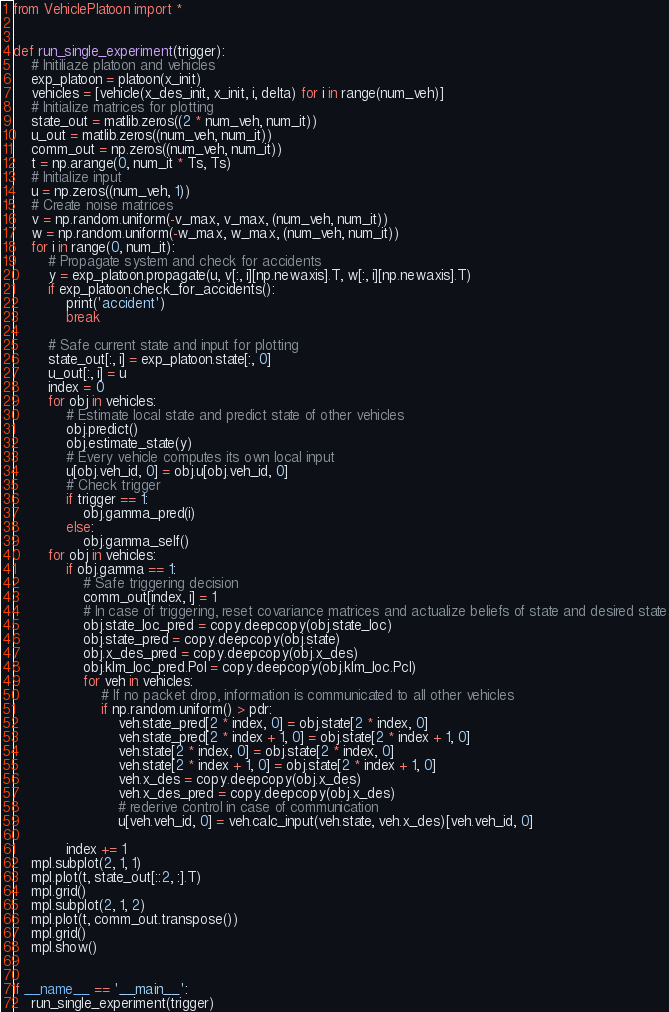<code> <loc_0><loc_0><loc_500><loc_500><_Python_>
from VehiclePlatoon import *


def run_single_experiment(trigger):
    # Initiliaze platoon and vehicles
    exp_platoon = platoon(x_init)
    vehicles = [vehicle(x_des_init, x_init, i, delta) for i in range(num_veh)]
    # Initialize matrices for plotting
    state_out = matlib.zeros((2 * num_veh, num_it))
    u_out = matlib.zeros((num_veh, num_it))
    comm_out = np.zeros((num_veh, num_it))
    t = np.arange(0, num_it * Ts, Ts)
    # Initialize input
    u = np.zeros((num_veh, 1))
    # Create noise matrices
    v = np.random.uniform(-v_max, v_max, (num_veh, num_it))
    w = np.random.uniform(-w_max, w_max, (num_veh, num_it))
    for i in range(0, num_it):
        # Propagate system and check for accidents
        y = exp_platoon.propagate(u, v[:, i][np.newaxis].T, w[:, i][np.newaxis].T)
        if exp_platoon.check_for_accidents():
            print('accident')
            break

        # Safe current state and input for plotting
        state_out[:, i] = exp_platoon.state[:, 0]
        u_out[:, i] = u
        index = 0
        for obj in vehicles:
            # Estimate local state and predict state of other vehicles
            obj.predict()
            obj.estimate_state(y)
            # Every vehicle computes its own local input
            u[obj.veh_id, 0] = obj.u[obj.veh_id, 0]
            # Check trigger
            if trigger == 1:
                obj.gamma_pred(i)
            else:
                obj.gamma_self()
        for obj in vehicles:
            if obj.gamma == 1:
                # Safe triggering decision
                comm_out[index, i] = 1
                # In case of triggering, reset covariance matrices and actualize beliefs of state and desired state
                obj.state_loc_pred = copy.deepcopy(obj.state_loc)
                obj.state_pred = copy.deepcopy(obj.state)
                obj.x_des_pred = copy.deepcopy(obj.x_des)
                obj.klm_loc_pred.Pol = copy.deepcopy(obj.klm_loc.Pcl)
                for veh in vehicles:
                    # If no packet drop, information is communicated to all other vehicles
                    if np.random.uniform() > pdr:
                        veh.state_pred[2 * index, 0] = obj.state[2 * index, 0]
                        veh.state_pred[2 * index + 1, 0] = obj.state[2 * index + 1, 0]
                        veh.state[2 * index, 0] = obj.state[2 * index, 0]
                        veh.state[2 * index + 1, 0] = obj.state[2 * index + 1, 0]
                        veh.x_des = copy.deepcopy(obj.x_des)
                        veh.x_des_pred = copy.deepcopy(obj.x_des)
                        # rederive control in case of communication
                        u[veh.veh_id, 0] = veh.calc_input(veh.state, veh.x_des)[veh.veh_id, 0]

            index += 1
    mpl.subplot(2, 1, 1)
    mpl.plot(t, state_out[::2, :].T)
    mpl.grid()
    mpl.subplot(2, 1, 2)
    mpl.plot(t, comm_out.transpose())
    mpl.grid()
    mpl.show()


if __name__ == '__main__':
    run_single_experiment(trigger)
</code> 